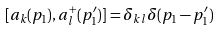Convert formula to latex. <formula><loc_0><loc_0><loc_500><loc_500>[ a _ { k } ( p _ { 1 } ) , a _ { l } ^ { + } ( p _ { 1 } ^ { \prime } ) ] = \delta _ { k l } \delta ( p _ { 1 } - p _ { 1 } ^ { \prime } )</formula> 